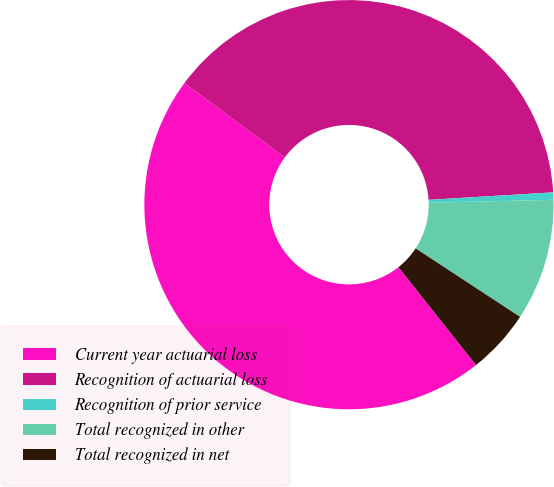Convert chart. <chart><loc_0><loc_0><loc_500><loc_500><pie_chart><fcel>Current year actuarial loss<fcel>Recognition of actuarial loss<fcel>Recognition of prior service<fcel>Total recognized in other<fcel>Total recognized in net<nl><fcel>45.79%<fcel>38.92%<fcel>0.58%<fcel>9.62%<fcel>5.1%<nl></chart> 